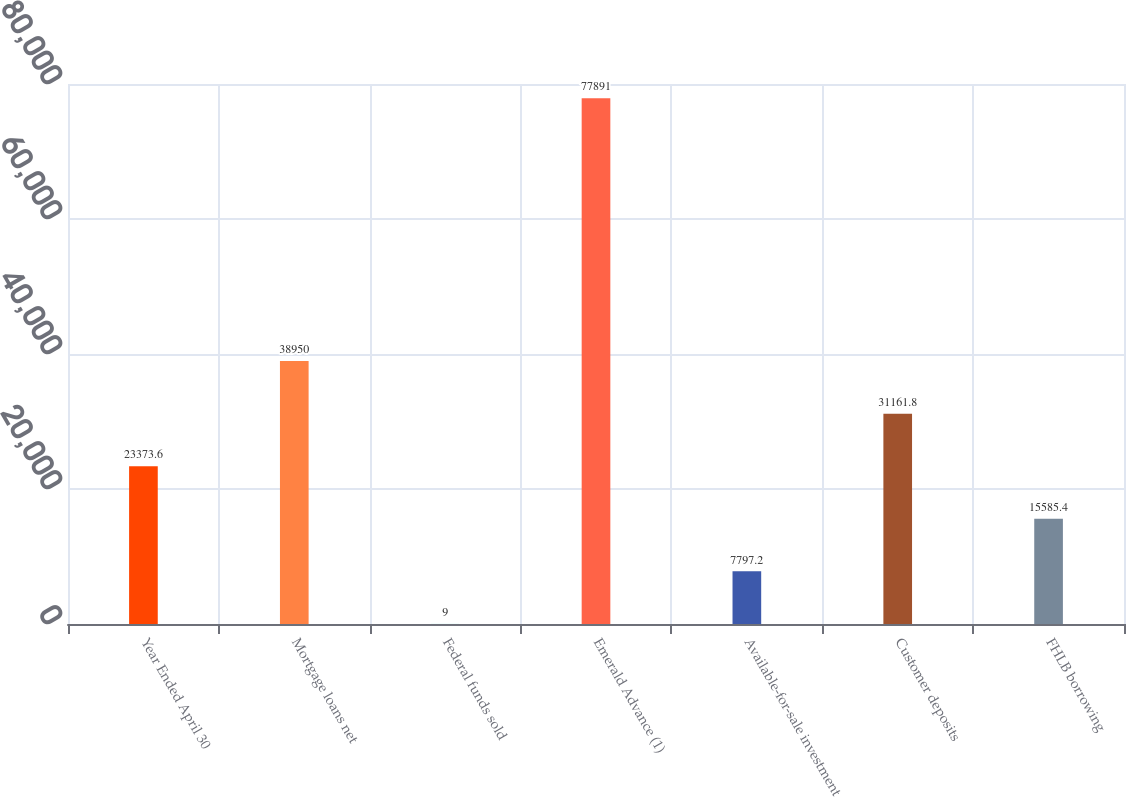Convert chart to OTSL. <chart><loc_0><loc_0><loc_500><loc_500><bar_chart><fcel>Year Ended April 30<fcel>Mortgage loans net<fcel>Federal funds sold<fcel>Emerald Advance (1)<fcel>Available-for-sale investment<fcel>Customer deposits<fcel>FHLB borrowing<nl><fcel>23373.6<fcel>38950<fcel>9<fcel>77891<fcel>7797.2<fcel>31161.8<fcel>15585.4<nl></chart> 